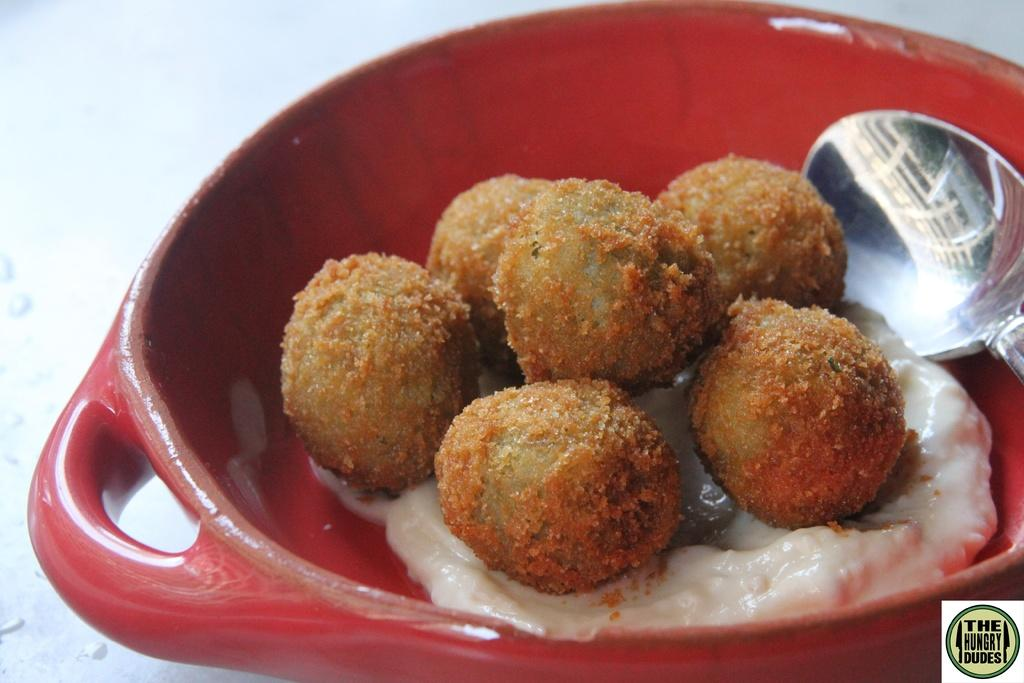What is in the bowl that is visible in the image? There is a bowl of food item in the image. What utensil is present in the image? A spoon is present in the image. What type of pie is being served by the laborer in the image? There is no pie or laborer present in the image. What type of gun is visible in the image? There is no gun present in the image. 